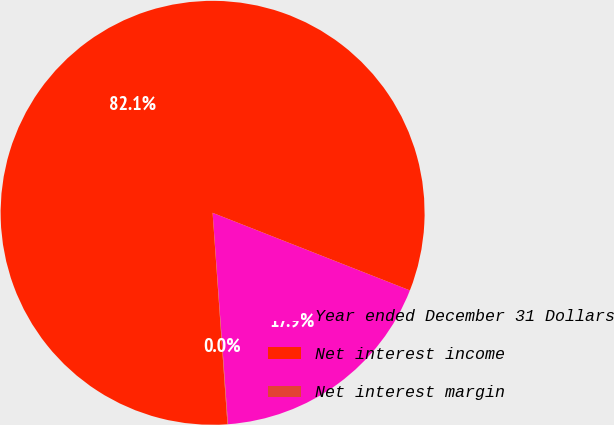Convert chart to OTSL. <chart><loc_0><loc_0><loc_500><loc_500><pie_chart><fcel>Year ended December 31 Dollars<fcel>Net interest income<fcel>Net interest margin<nl><fcel>17.88%<fcel>82.09%<fcel>0.04%<nl></chart> 